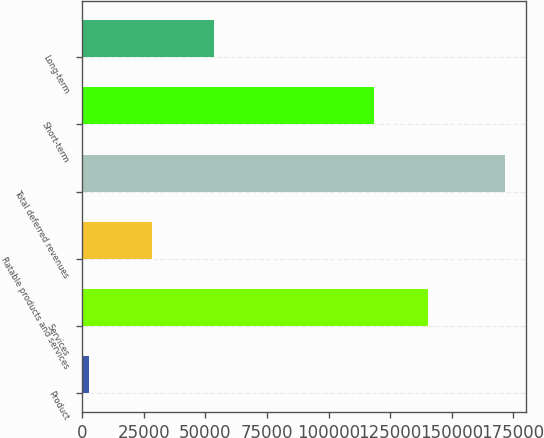Convert chart to OTSL. <chart><loc_0><loc_0><loc_500><loc_500><bar_chart><fcel>Product<fcel>Services<fcel>Ratable products and services<fcel>Total deferred revenues<fcel>Short-term<fcel>Long-term<nl><fcel>2731<fcel>140407<fcel>28479<fcel>171617<fcel>118297<fcel>53320<nl></chart> 